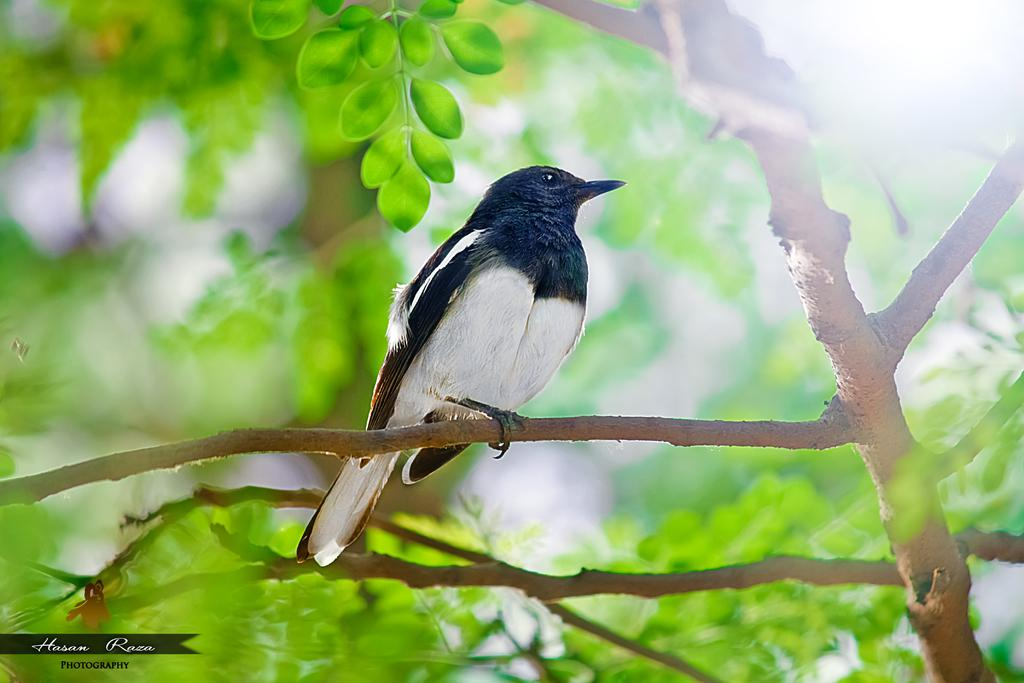What type of animal can be seen in the image? There is a bird in the image. Where is the bird located? The bird is on a tree. What type of music can be heard playing in the background of the image? There is no music present in the image, as it only features a bird on a tree. 